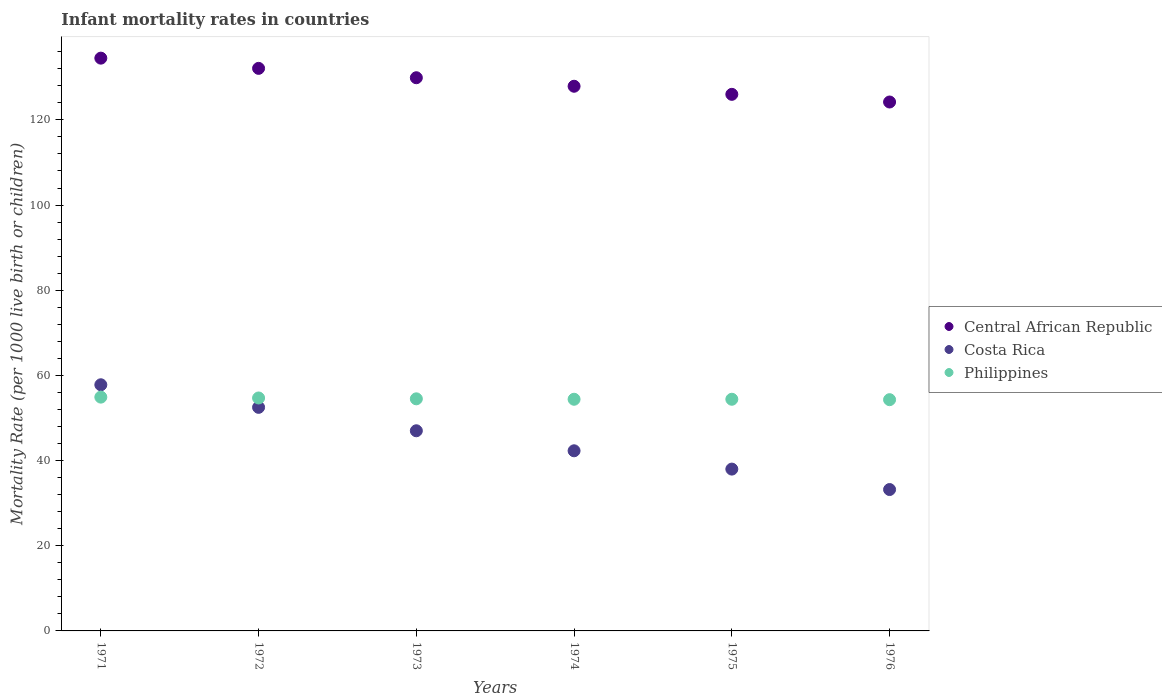How many different coloured dotlines are there?
Give a very brief answer. 3. What is the infant mortality rate in Central African Republic in 1974?
Give a very brief answer. 127.9. Across all years, what is the maximum infant mortality rate in Central African Republic?
Your answer should be very brief. 134.5. Across all years, what is the minimum infant mortality rate in Philippines?
Offer a very short reply. 54.3. In which year was the infant mortality rate in Central African Republic maximum?
Offer a very short reply. 1971. In which year was the infant mortality rate in Costa Rica minimum?
Give a very brief answer. 1976. What is the total infant mortality rate in Costa Rica in the graph?
Provide a short and direct response. 270.8. What is the difference between the infant mortality rate in Costa Rica in 1975 and that in 1976?
Your response must be concise. 4.8. What is the difference between the infant mortality rate in Philippines in 1975 and the infant mortality rate in Central African Republic in 1972?
Your answer should be very brief. -77.7. What is the average infant mortality rate in Central African Republic per year?
Provide a short and direct response. 129.1. In the year 1975, what is the difference between the infant mortality rate in Central African Republic and infant mortality rate in Costa Rica?
Ensure brevity in your answer.  88. What is the ratio of the infant mortality rate in Philippines in 1971 to that in 1976?
Ensure brevity in your answer.  1.01. Is the infant mortality rate in Central African Republic in 1971 less than that in 1975?
Your answer should be compact. No. Is the difference between the infant mortality rate in Central African Republic in 1974 and 1975 greater than the difference between the infant mortality rate in Costa Rica in 1974 and 1975?
Ensure brevity in your answer.  No. What is the difference between the highest and the second highest infant mortality rate in Costa Rica?
Make the answer very short. 5.3. What is the difference between the highest and the lowest infant mortality rate in Costa Rica?
Offer a terse response. 24.6. In how many years, is the infant mortality rate in Costa Rica greater than the average infant mortality rate in Costa Rica taken over all years?
Provide a succinct answer. 3. Is it the case that in every year, the sum of the infant mortality rate in Central African Republic and infant mortality rate in Philippines  is greater than the infant mortality rate in Costa Rica?
Give a very brief answer. Yes. Does the infant mortality rate in Central African Republic monotonically increase over the years?
Your answer should be very brief. No. Is the infant mortality rate in Costa Rica strictly less than the infant mortality rate in Central African Republic over the years?
Keep it short and to the point. Yes. What is the difference between two consecutive major ticks on the Y-axis?
Offer a terse response. 20. Does the graph contain any zero values?
Provide a succinct answer. No. Does the graph contain grids?
Provide a succinct answer. No. How are the legend labels stacked?
Provide a short and direct response. Vertical. What is the title of the graph?
Make the answer very short. Infant mortality rates in countries. What is the label or title of the Y-axis?
Your response must be concise. Mortality Rate (per 1000 live birth or children). What is the Mortality Rate (per 1000 live birth or children) in Central African Republic in 1971?
Offer a very short reply. 134.5. What is the Mortality Rate (per 1000 live birth or children) of Costa Rica in 1971?
Your response must be concise. 57.8. What is the Mortality Rate (per 1000 live birth or children) of Philippines in 1971?
Keep it short and to the point. 54.9. What is the Mortality Rate (per 1000 live birth or children) in Central African Republic in 1972?
Your response must be concise. 132.1. What is the Mortality Rate (per 1000 live birth or children) in Costa Rica in 1972?
Offer a very short reply. 52.5. What is the Mortality Rate (per 1000 live birth or children) in Philippines in 1972?
Your answer should be compact. 54.7. What is the Mortality Rate (per 1000 live birth or children) in Central African Republic in 1973?
Give a very brief answer. 129.9. What is the Mortality Rate (per 1000 live birth or children) of Costa Rica in 1973?
Your answer should be very brief. 47. What is the Mortality Rate (per 1000 live birth or children) of Philippines in 1973?
Offer a very short reply. 54.5. What is the Mortality Rate (per 1000 live birth or children) in Central African Republic in 1974?
Your answer should be very brief. 127.9. What is the Mortality Rate (per 1000 live birth or children) in Costa Rica in 1974?
Give a very brief answer. 42.3. What is the Mortality Rate (per 1000 live birth or children) in Philippines in 1974?
Your answer should be compact. 54.4. What is the Mortality Rate (per 1000 live birth or children) of Central African Republic in 1975?
Your answer should be compact. 126. What is the Mortality Rate (per 1000 live birth or children) in Costa Rica in 1975?
Make the answer very short. 38. What is the Mortality Rate (per 1000 live birth or children) of Philippines in 1975?
Provide a succinct answer. 54.4. What is the Mortality Rate (per 1000 live birth or children) of Central African Republic in 1976?
Ensure brevity in your answer.  124.2. What is the Mortality Rate (per 1000 live birth or children) of Costa Rica in 1976?
Give a very brief answer. 33.2. What is the Mortality Rate (per 1000 live birth or children) of Philippines in 1976?
Provide a succinct answer. 54.3. Across all years, what is the maximum Mortality Rate (per 1000 live birth or children) in Central African Republic?
Give a very brief answer. 134.5. Across all years, what is the maximum Mortality Rate (per 1000 live birth or children) in Costa Rica?
Provide a short and direct response. 57.8. Across all years, what is the maximum Mortality Rate (per 1000 live birth or children) of Philippines?
Offer a very short reply. 54.9. Across all years, what is the minimum Mortality Rate (per 1000 live birth or children) in Central African Republic?
Make the answer very short. 124.2. Across all years, what is the minimum Mortality Rate (per 1000 live birth or children) of Costa Rica?
Your response must be concise. 33.2. Across all years, what is the minimum Mortality Rate (per 1000 live birth or children) in Philippines?
Your response must be concise. 54.3. What is the total Mortality Rate (per 1000 live birth or children) of Central African Republic in the graph?
Your answer should be very brief. 774.6. What is the total Mortality Rate (per 1000 live birth or children) in Costa Rica in the graph?
Keep it short and to the point. 270.8. What is the total Mortality Rate (per 1000 live birth or children) in Philippines in the graph?
Your response must be concise. 327.2. What is the difference between the Mortality Rate (per 1000 live birth or children) of Central African Republic in 1971 and that in 1972?
Give a very brief answer. 2.4. What is the difference between the Mortality Rate (per 1000 live birth or children) in Costa Rica in 1971 and that in 1972?
Provide a short and direct response. 5.3. What is the difference between the Mortality Rate (per 1000 live birth or children) in Philippines in 1971 and that in 1974?
Make the answer very short. 0.5. What is the difference between the Mortality Rate (per 1000 live birth or children) in Central African Republic in 1971 and that in 1975?
Your answer should be very brief. 8.5. What is the difference between the Mortality Rate (per 1000 live birth or children) of Costa Rica in 1971 and that in 1975?
Make the answer very short. 19.8. What is the difference between the Mortality Rate (per 1000 live birth or children) of Philippines in 1971 and that in 1975?
Provide a succinct answer. 0.5. What is the difference between the Mortality Rate (per 1000 live birth or children) in Costa Rica in 1971 and that in 1976?
Provide a succinct answer. 24.6. What is the difference between the Mortality Rate (per 1000 live birth or children) of Costa Rica in 1972 and that in 1973?
Provide a short and direct response. 5.5. What is the difference between the Mortality Rate (per 1000 live birth or children) of Philippines in 1972 and that in 1973?
Offer a terse response. 0.2. What is the difference between the Mortality Rate (per 1000 live birth or children) of Philippines in 1972 and that in 1974?
Give a very brief answer. 0.3. What is the difference between the Mortality Rate (per 1000 live birth or children) in Costa Rica in 1972 and that in 1975?
Give a very brief answer. 14.5. What is the difference between the Mortality Rate (per 1000 live birth or children) of Central African Republic in 1972 and that in 1976?
Provide a succinct answer. 7.9. What is the difference between the Mortality Rate (per 1000 live birth or children) in Costa Rica in 1972 and that in 1976?
Your response must be concise. 19.3. What is the difference between the Mortality Rate (per 1000 live birth or children) in Philippines in 1972 and that in 1976?
Keep it short and to the point. 0.4. What is the difference between the Mortality Rate (per 1000 live birth or children) of Philippines in 1973 and that in 1974?
Offer a terse response. 0.1. What is the difference between the Mortality Rate (per 1000 live birth or children) in Central African Republic in 1973 and that in 1975?
Provide a short and direct response. 3.9. What is the difference between the Mortality Rate (per 1000 live birth or children) in Costa Rica in 1973 and that in 1975?
Give a very brief answer. 9. What is the difference between the Mortality Rate (per 1000 live birth or children) of Philippines in 1973 and that in 1975?
Your response must be concise. 0.1. What is the difference between the Mortality Rate (per 1000 live birth or children) in Central African Republic in 1973 and that in 1976?
Offer a very short reply. 5.7. What is the difference between the Mortality Rate (per 1000 live birth or children) of Philippines in 1973 and that in 1976?
Provide a succinct answer. 0.2. What is the difference between the Mortality Rate (per 1000 live birth or children) of Central African Republic in 1974 and that in 1975?
Offer a very short reply. 1.9. What is the difference between the Mortality Rate (per 1000 live birth or children) of Philippines in 1974 and that in 1975?
Your response must be concise. 0. What is the difference between the Mortality Rate (per 1000 live birth or children) in Central African Republic in 1974 and that in 1976?
Keep it short and to the point. 3.7. What is the difference between the Mortality Rate (per 1000 live birth or children) in Costa Rica in 1974 and that in 1976?
Give a very brief answer. 9.1. What is the difference between the Mortality Rate (per 1000 live birth or children) in Philippines in 1974 and that in 1976?
Your answer should be compact. 0.1. What is the difference between the Mortality Rate (per 1000 live birth or children) in Central African Republic in 1975 and that in 1976?
Make the answer very short. 1.8. What is the difference between the Mortality Rate (per 1000 live birth or children) of Central African Republic in 1971 and the Mortality Rate (per 1000 live birth or children) of Philippines in 1972?
Make the answer very short. 79.8. What is the difference between the Mortality Rate (per 1000 live birth or children) of Costa Rica in 1971 and the Mortality Rate (per 1000 live birth or children) of Philippines in 1972?
Provide a succinct answer. 3.1. What is the difference between the Mortality Rate (per 1000 live birth or children) of Central African Republic in 1971 and the Mortality Rate (per 1000 live birth or children) of Costa Rica in 1973?
Make the answer very short. 87.5. What is the difference between the Mortality Rate (per 1000 live birth or children) of Costa Rica in 1971 and the Mortality Rate (per 1000 live birth or children) of Philippines in 1973?
Make the answer very short. 3.3. What is the difference between the Mortality Rate (per 1000 live birth or children) in Central African Republic in 1971 and the Mortality Rate (per 1000 live birth or children) in Costa Rica in 1974?
Your answer should be compact. 92.2. What is the difference between the Mortality Rate (per 1000 live birth or children) of Central African Republic in 1971 and the Mortality Rate (per 1000 live birth or children) of Philippines in 1974?
Your answer should be compact. 80.1. What is the difference between the Mortality Rate (per 1000 live birth or children) of Costa Rica in 1971 and the Mortality Rate (per 1000 live birth or children) of Philippines in 1974?
Your answer should be compact. 3.4. What is the difference between the Mortality Rate (per 1000 live birth or children) of Central African Republic in 1971 and the Mortality Rate (per 1000 live birth or children) of Costa Rica in 1975?
Make the answer very short. 96.5. What is the difference between the Mortality Rate (per 1000 live birth or children) in Central African Republic in 1971 and the Mortality Rate (per 1000 live birth or children) in Philippines in 1975?
Keep it short and to the point. 80.1. What is the difference between the Mortality Rate (per 1000 live birth or children) in Central African Republic in 1971 and the Mortality Rate (per 1000 live birth or children) in Costa Rica in 1976?
Your response must be concise. 101.3. What is the difference between the Mortality Rate (per 1000 live birth or children) in Central African Republic in 1971 and the Mortality Rate (per 1000 live birth or children) in Philippines in 1976?
Provide a short and direct response. 80.2. What is the difference between the Mortality Rate (per 1000 live birth or children) of Costa Rica in 1971 and the Mortality Rate (per 1000 live birth or children) of Philippines in 1976?
Give a very brief answer. 3.5. What is the difference between the Mortality Rate (per 1000 live birth or children) of Central African Republic in 1972 and the Mortality Rate (per 1000 live birth or children) of Costa Rica in 1973?
Your answer should be very brief. 85.1. What is the difference between the Mortality Rate (per 1000 live birth or children) in Central African Republic in 1972 and the Mortality Rate (per 1000 live birth or children) in Philippines in 1973?
Ensure brevity in your answer.  77.6. What is the difference between the Mortality Rate (per 1000 live birth or children) in Central African Republic in 1972 and the Mortality Rate (per 1000 live birth or children) in Costa Rica in 1974?
Your answer should be compact. 89.8. What is the difference between the Mortality Rate (per 1000 live birth or children) in Central African Republic in 1972 and the Mortality Rate (per 1000 live birth or children) in Philippines in 1974?
Offer a very short reply. 77.7. What is the difference between the Mortality Rate (per 1000 live birth or children) of Central African Republic in 1972 and the Mortality Rate (per 1000 live birth or children) of Costa Rica in 1975?
Ensure brevity in your answer.  94.1. What is the difference between the Mortality Rate (per 1000 live birth or children) in Central African Republic in 1972 and the Mortality Rate (per 1000 live birth or children) in Philippines in 1975?
Give a very brief answer. 77.7. What is the difference between the Mortality Rate (per 1000 live birth or children) in Central African Republic in 1972 and the Mortality Rate (per 1000 live birth or children) in Costa Rica in 1976?
Offer a terse response. 98.9. What is the difference between the Mortality Rate (per 1000 live birth or children) of Central African Republic in 1972 and the Mortality Rate (per 1000 live birth or children) of Philippines in 1976?
Make the answer very short. 77.8. What is the difference between the Mortality Rate (per 1000 live birth or children) of Central African Republic in 1973 and the Mortality Rate (per 1000 live birth or children) of Costa Rica in 1974?
Your answer should be very brief. 87.6. What is the difference between the Mortality Rate (per 1000 live birth or children) in Central African Republic in 1973 and the Mortality Rate (per 1000 live birth or children) in Philippines in 1974?
Offer a very short reply. 75.5. What is the difference between the Mortality Rate (per 1000 live birth or children) of Central African Republic in 1973 and the Mortality Rate (per 1000 live birth or children) of Costa Rica in 1975?
Offer a terse response. 91.9. What is the difference between the Mortality Rate (per 1000 live birth or children) of Central African Republic in 1973 and the Mortality Rate (per 1000 live birth or children) of Philippines in 1975?
Your answer should be compact. 75.5. What is the difference between the Mortality Rate (per 1000 live birth or children) in Costa Rica in 1973 and the Mortality Rate (per 1000 live birth or children) in Philippines in 1975?
Your response must be concise. -7.4. What is the difference between the Mortality Rate (per 1000 live birth or children) in Central African Republic in 1973 and the Mortality Rate (per 1000 live birth or children) in Costa Rica in 1976?
Your answer should be very brief. 96.7. What is the difference between the Mortality Rate (per 1000 live birth or children) in Central African Republic in 1973 and the Mortality Rate (per 1000 live birth or children) in Philippines in 1976?
Provide a succinct answer. 75.6. What is the difference between the Mortality Rate (per 1000 live birth or children) of Costa Rica in 1973 and the Mortality Rate (per 1000 live birth or children) of Philippines in 1976?
Offer a very short reply. -7.3. What is the difference between the Mortality Rate (per 1000 live birth or children) in Central African Republic in 1974 and the Mortality Rate (per 1000 live birth or children) in Costa Rica in 1975?
Offer a very short reply. 89.9. What is the difference between the Mortality Rate (per 1000 live birth or children) of Central African Republic in 1974 and the Mortality Rate (per 1000 live birth or children) of Philippines in 1975?
Your answer should be very brief. 73.5. What is the difference between the Mortality Rate (per 1000 live birth or children) in Central African Republic in 1974 and the Mortality Rate (per 1000 live birth or children) in Costa Rica in 1976?
Provide a short and direct response. 94.7. What is the difference between the Mortality Rate (per 1000 live birth or children) of Central African Republic in 1974 and the Mortality Rate (per 1000 live birth or children) of Philippines in 1976?
Keep it short and to the point. 73.6. What is the difference between the Mortality Rate (per 1000 live birth or children) in Central African Republic in 1975 and the Mortality Rate (per 1000 live birth or children) in Costa Rica in 1976?
Your answer should be very brief. 92.8. What is the difference between the Mortality Rate (per 1000 live birth or children) of Central African Republic in 1975 and the Mortality Rate (per 1000 live birth or children) of Philippines in 1976?
Your answer should be compact. 71.7. What is the difference between the Mortality Rate (per 1000 live birth or children) of Costa Rica in 1975 and the Mortality Rate (per 1000 live birth or children) of Philippines in 1976?
Give a very brief answer. -16.3. What is the average Mortality Rate (per 1000 live birth or children) in Central African Republic per year?
Make the answer very short. 129.1. What is the average Mortality Rate (per 1000 live birth or children) of Costa Rica per year?
Give a very brief answer. 45.13. What is the average Mortality Rate (per 1000 live birth or children) in Philippines per year?
Make the answer very short. 54.53. In the year 1971, what is the difference between the Mortality Rate (per 1000 live birth or children) of Central African Republic and Mortality Rate (per 1000 live birth or children) of Costa Rica?
Your answer should be compact. 76.7. In the year 1971, what is the difference between the Mortality Rate (per 1000 live birth or children) of Central African Republic and Mortality Rate (per 1000 live birth or children) of Philippines?
Offer a terse response. 79.6. In the year 1971, what is the difference between the Mortality Rate (per 1000 live birth or children) of Costa Rica and Mortality Rate (per 1000 live birth or children) of Philippines?
Your answer should be very brief. 2.9. In the year 1972, what is the difference between the Mortality Rate (per 1000 live birth or children) in Central African Republic and Mortality Rate (per 1000 live birth or children) in Costa Rica?
Ensure brevity in your answer.  79.6. In the year 1972, what is the difference between the Mortality Rate (per 1000 live birth or children) of Central African Republic and Mortality Rate (per 1000 live birth or children) of Philippines?
Offer a very short reply. 77.4. In the year 1972, what is the difference between the Mortality Rate (per 1000 live birth or children) in Costa Rica and Mortality Rate (per 1000 live birth or children) in Philippines?
Your response must be concise. -2.2. In the year 1973, what is the difference between the Mortality Rate (per 1000 live birth or children) of Central African Republic and Mortality Rate (per 1000 live birth or children) of Costa Rica?
Offer a terse response. 82.9. In the year 1973, what is the difference between the Mortality Rate (per 1000 live birth or children) in Central African Republic and Mortality Rate (per 1000 live birth or children) in Philippines?
Keep it short and to the point. 75.4. In the year 1973, what is the difference between the Mortality Rate (per 1000 live birth or children) of Costa Rica and Mortality Rate (per 1000 live birth or children) of Philippines?
Offer a very short reply. -7.5. In the year 1974, what is the difference between the Mortality Rate (per 1000 live birth or children) in Central African Republic and Mortality Rate (per 1000 live birth or children) in Costa Rica?
Offer a terse response. 85.6. In the year 1974, what is the difference between the Mortality Rate (per 1000 live birth or children) in Central African Republic and Mortality Rate (per 1000 live birth or children) in Philippines?
Your answer should be very brief. 73.5. In the year 1974, what is the difference between the Mortality Rate (per 1000 live birth or children) of Costa Rica and Mortality Rate (per 1000 live birth or children) of Philippines?
Offer a very short reply. -12.1. In the year 1975, what is the difference between the Mortality Rate (per 1000 live birth or children) in Central African Republic and Mortality Rate (per 1000 live birth or children) in Costa Rica?
Your answer should be very brief. 88. In the year 1975, what is the difference between the Mortality Rate (per 1000 live birth or children) in Central African Republic and Mortality Rate (per 1000 live birth or children) in Philippines?
Provide a short and direct response. 71.6. In the year 1975, what is the difference between the Mortality Rate (per 1000 live birth or children) of Costa Rica and Mortality Rate (per 1000 live birth or children) of Philippines?
Provide a succinct answer. -16.4. In the year 1976, what is the difference between the Mortality Rate (per 1000 live birth or children) of Central African Republic and Mortality Rate (per 1000 live birth or children) of Costa Rica?
Your response must be concise. 91. In the year 1976, what is the difference between the Mortality Rate (per 1000 live birth or children) in Central African Republic and Mortality Rate (per 1000 live birth or children) in Philippines?
Provide a succinct answer. 69.9. In the year 1976, what is the difference between the Mortality Rate (per 1000 live birth or children) of Costa Rica and Mortality Rate (per 1000 live birth or children) of Philippines?
Keep it short and to the point. -21.1. What is the ratio of the Mortality Rate (per 1000 live birth or children) in Central African Republic in 1971 to that in 1972?
Your answer should be very brief. 1.02. What is the ratio of the Mortality Rate (per 1000 live birth or children) of Costa Rica in 1971 to that in 1972?
Provide a succinct answer. 1.1. What is the ratio of the Mortality Rate (per 1000 live birth or children) of Philippines in 1971 to that in 1972?
Make the answer very short. 1. What is the ratio of the Mortality Rate (per 1000 live birth or children) in Central African Republic in 1971 to that in 1973?
Offer a terse response. 1.04. What is the ratio of the Mortality Rate (per 1000 live birth or children) in Costa Rica in 1971 to that in 1973?
Make the answer very short. 1.23. What is the ratio of the Mortality Rate (per 1000 live birth or children) in Philippines in 1971 to that in 1973?
Make the answer very short. 1.01. What is the ratio of the Mortality Rate (per 1000 live birth or children) of Central African Republic in 1971 to that in 1974?
Offer a very short reply. 1.05. What is the ratio of the Mortality Rate (per 1000 live birth or children) of Costa Rica in 1971 to that in 1974?
Provide a short and direct response. 1.37. What is the ratio of the Mortality Rate (per 1000 live birth or children) of Philippines in 1971 to that in 1974?
Make the answer very short. 1.01. What is the ratio of the Mortality Rate (per 1000 live birth or children) in Central African Republic in 1971 to that in 1975?
Keep it short and to the point. 1.07. What is the ratio of the Mortality Rate (per 1000 live birth or children) of Costa Rica in 1971 to that in 1975?
Your answer should be very brief. 1.52. What is the ratio of the Mortality Rate (per 1000 live birth or children) of Philippines in 1971 to that in 1975?
Offer a very short reply. 1.01. What is the ratio of the Mortality Rate (per 1000 live birth or children) in Central African Republic in 1971 to that in 1976?
Your answer should be very brief. 1.08. What is the ratio of the Mortality Rate (per 1000 live birth or children) of Costa Rica in 1971 to that in 1976?
Make the answer very short. 1.74. What is the ratio of the Mortality Rate (per 1000 live birth or children) of Philippines in 1971 to that in 1976?
Make the answer very short. 1.01. What is the ratio of the Mortality Rate (per 1000 live birth or children) of Central African Republic in 1972 to that in 1973?
Give a very brief answer. 1.02. What is the ratio of the Mortality Rate (per 1000 live birth or children) in Costa Rica in 1972 to that in 1973?
Your answer should be compact. 1.12. What is the ratio of the Mortality Rate (per 1000 live birth or children) in Central African Republic in 1972 to that in 1974?
Give a very brief answer. 1.03. What is the ratio of the Mortality Rate (per 1000 live birth or children) of Costa Rica in 1972 to that in 1974?
Ensure brevity in your answer.  1.24. What is the ratio of the Mortality Rate (per 1000 live birth or children) of Central African Republic in 1972 to that in 1975?
Give a very brief answer. 1.05. What is the ratio of the Mortality Rate (per 1000 live birth or children) in Costa Rica in 1972 to that in 1975?
Your response must be concise. 1.38. What is the ratio of the Mortality Rate (per 1000 live birth or children) of Central African Republic in 1972 to that in 1976?
Keep it short and to the point. 1.06. What is the ratio of the Mortality Rate (per 1000 live birth or children) of Costa Rica in 1972 to that in 1976?
Your answer should be compact. 1.58. What is the ratio of the Mortality Rate (per 1000 live birth or children) in Philippines in 1972 to that in 1976?
Provide a short and direct response. 1.01. What is the ratio of the Mortality Rate (per 1000 live birth or children) of Central African Republic in 1973 to that in 1974?
Keep it short and to the point. 1.02. What is the ratio of the Mortality Rate (per 1000 live birth or children) in Philippines in 1973 to that in 1974?
Ensure brevity in your answer.  1. What is the ratio of the Mortality Rate (per 1000 live birth or children) of Central African Republic in 1973 to that in 1975?
Your answer should be compact. 1.03. What is the ratio of the Mortality Rate (per 1000 live birth or children) in Costa Rica in 1973 to that in 1975?
Provide a short and direct response. 1.24. What is the ratio of the Mortality Rate (per 1000 live birth or children) in Central African Republic in 1973 to that in 1976?
Offer a terse response. 1.05. What is the ratio of the Mortality Rate (per 1000 live birth or children) of Costa Rica in 1973 to that in 1976?
Offer a very short reply. 1.42. What is the ratio of the Mortality Rate (per 1000 live birth or children) of Philippines in 1973 to that in 1976?
Provide a short and direct response. 1. What is the ratio of the Mortality Rate (per 1000 live birth or children) of Central African Republic in 1974 to that in 1975?
Your answer should be very brief. 1.02. What is the ratio of the Mortality Rate (per 1000 live birth or children) of Costa Rica in 1974 to that in 1975?
Provide a succinct answer. 1.11. What is the ratio of the Mortality Rate (per 1000 live birth or children) of Central African Republic in 1974 to that in 1976?
Make the answer very short. 1.03. What is the ratio of the Mortality Rate (per 1000 live birth or children) in Costa Rica in 1974 to that in 1976?
Make the answer very short. 1.27. What is the ratio of the Mortality Rate (per 1000 live birth or children) of Philippines in 1974 to that in 1976?
Your answer should be very brief. 1. What is the ratio of the Mortality Rate (per 1000 live birth or children) of Central African Republic in 1975 to that in 1976?
Your answer should be very brief. 1.01. What is the ratio of the Mortality Rate (per 1000 live birth or children) in Costa Rica in 1975 to that in 1976?
Give a very brief answer. 1.14. What is the ratio of the Mortality Rate (per 1000 live birth or children) of Philippines in 1975 to that in 1976?
Your response must be concise. 1. What is the difference between the highest and the second highest Mortality Rate (per 1000 live birth or children) in Costa Rica?
Offer a terse response. 5.3. What is the difference between the highest and the second highest Mortality Rate (per 1000 live birth or children) in Philippines?
Your answer should be very brief. 0.2. What is the difference between the highest and the lowest Mortality Rate (per 1000 live birth or children) of Central African Republic?
Give a very brief answer. 10.3. What is the difference between the highest and the lowest Mortality Rate (per 1000 live birth or children) of Costa Rica?
Your response must be concise. 24.6. What is the difference between the highest and the lowest Mortality Rate (per 1000 live birth or children) of Philippines?
Your response must be concise. 0.6. 